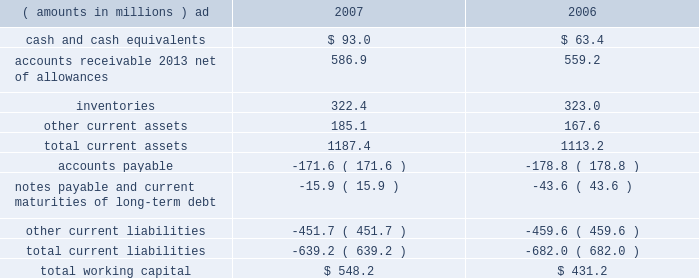2007 annual report 39 corporate snap-on 2019s general corporate expenses totaled $ 53.8 million in 2006 , up from $ 46.4 million in 2005 , primarily due to $ 15.2 million of increased stock-based and performance-based incentive compensation , including $ 6.3 million from the january 1 , 2006 , adoption of sfas no .
123 ( r ) .
Increased expenses in 2006 also included $ 4.2 million of higher insurance and other costs .
These expense increases were partially offset by $ 9.5 million of benefits from rci initiatives .
See note 13 to the consolidated financial statements for information on the company 2019s adoption of sfas no .
123 ( r ) .
Financial condition snap-on 2019s growth has historically been funded by a combination of cash provided by operating activities and debt financing .
Snap-on believes that its cash from operations , coupled with its sources of borrowings , are sufficient to fund its anticipated requirements for working capital , capital expenditures , restructuring activities , acquisitions , common stock repurchases and dividend payments .
Due to snap-on 2019s credit rating over the years , external funds have been available at a reasonable cost .
As of the close of business on february 15 , 2008 , snap-on 2019s long-term debt and commercial paper was rated a3 and p-2 by moody 2019s investors service and a- and a-2 by standard & poor 2019s .
Snap-on believes that the strength of its balance sheet , combined with its cash flows from operating activities , affords the company the financial flexibility to respond to both internal growth opportunities and those available through acquisitions .
The following discussion focuses on information included in the accompanying consolidated balance sheets .
Snap-on has been focused on improving asset utilization by making more effective use of its investment in certain working capital items .
The company assesses management 2019s operating performance and effectiveness relative to those components of working capital , particularly accounts receivable and inventories , that are more directly impacted by operational decisions .
As of december 29 , 2007 , working capital ( current assets less current liabilities ) of $ 548.2 million was up $ 117.0 million from $ 431.2 million as of december 30 , 2006 .
The increase in year-over-year working capital primarily reflects higher levels of 201ccash and cash equivalents 201d of $ 29.6 million , lower 201cnotes payable and current maturities of long-term debt 201d of $ 27.7 million , and $ 27.7 million of increased 201caccounts receivable 2013 net of allowances . 201d the following represents the company 2019s working capital position as of december 29 , 2007 , and december 30 , 2006 .
( amounts in millions ) 2007 2006 .
Accounts receivable at the end of 2007 was $ 586.9 million , up $ 27.7 million from year-end 2006 levels .
The year-over- year increase in accounts receivable primarily reflects the impact of higher sales in the fourth quarter of 2007 and $ 25.1 million of currency translation .
This increase in accounts receivable was partially offset by lower levels of receivables as a result of an improvement in days sales outstanding from 76 days at year-end 2006 to 73 days at year-end 2007. .
What is the percentage change in total current liabilities from 2006 to 2007? 
Computations: ((639.2 - 682.0) / 682.0)
Answer: -0.06276. 